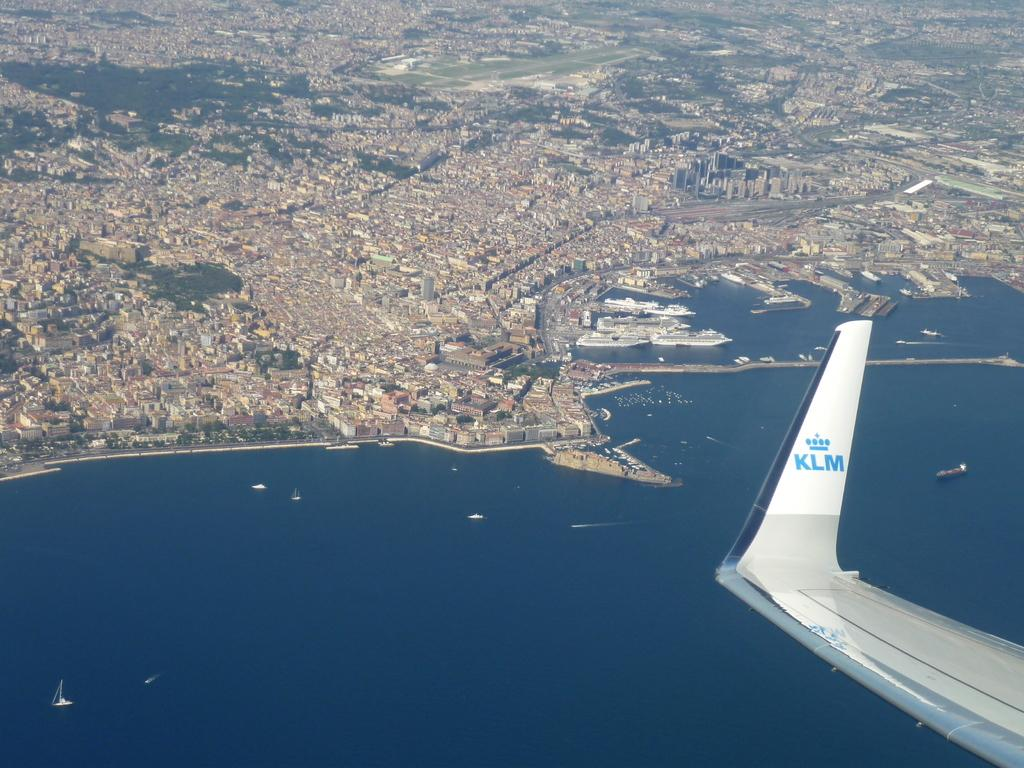<image>
Relay a brief, clear account of the picture shown. the end of a plane wing that shows the letters 'klm' on it 